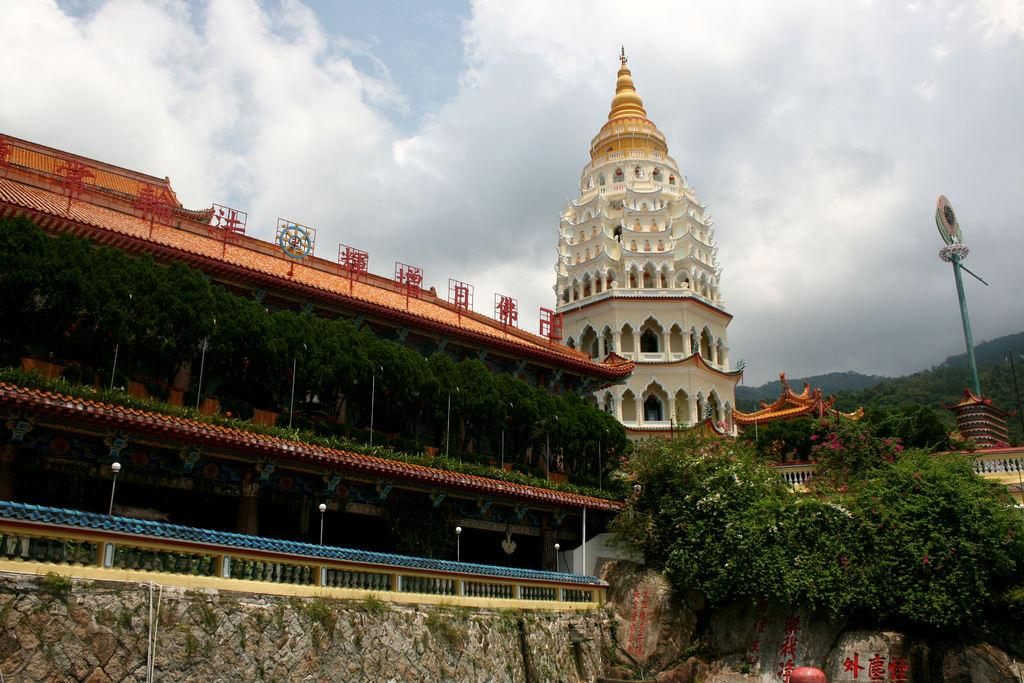What type of structures can be seen in the image? There are buildings in the image. What other objects are present in the image besides buildings? There are sign boards and poles in the image. What type of vegetation can be seen in the image? There is grass, plants, and trees in the image. What is visible in the sky in the image? The sky is visible in the image, and clouds are present. Can you see any flesh in the image? No, there is no flesh visible in the image. What type of writing can be seen on the sign boards in the image? There is no writing visible on the sign boards in the image; only the sign boards themselves are present. 